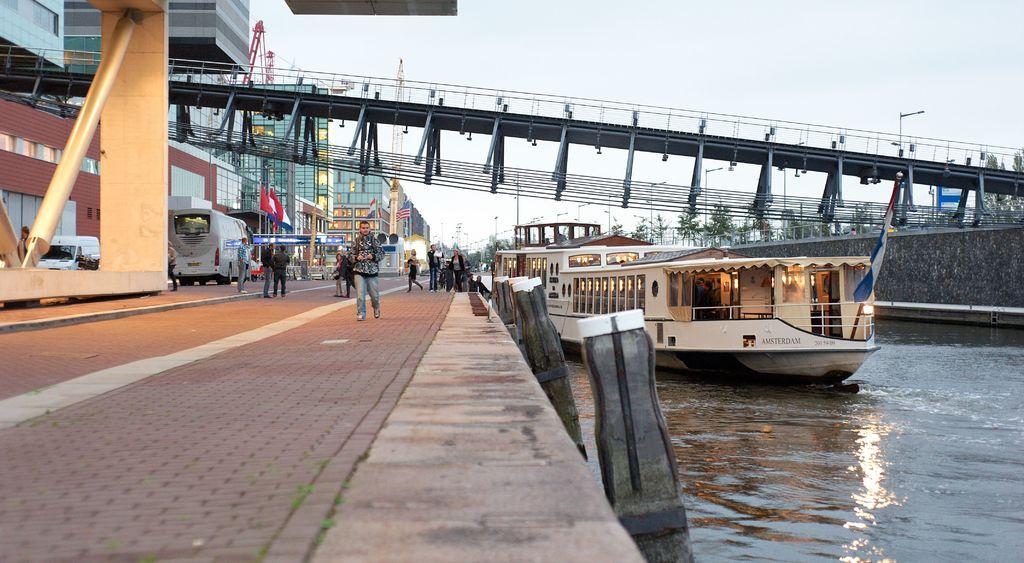How would you summarize this image in a sentence or two? To the right side bottom of the image there is water. On the water there is a ship. And to the left side there is a platform with few people are walking on it. In the background there are there are buildings, cars and few other vehicles. In the middle front the left to right there is a bridge. And also there are street lights and to the top of the image there is a sky. 